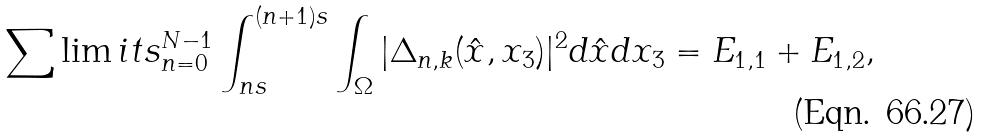Convert formula to latex. <formula><loc_0><loc_0><loc_500><loc_500>\sum \lim i t s _ { n = 0 } ^ { N - 1 } \int _ { n s } ^ { ( n + 1 ) s } \int _ { \Omega } | \Delta _ { n , k } ( \hat { x } , x _ { 3 } ) | ^ { 2 } d \hat { x } d x _ { 3 } = E _ { 1 , 1 } + E _ { 1 , 2 } ,</formula> 